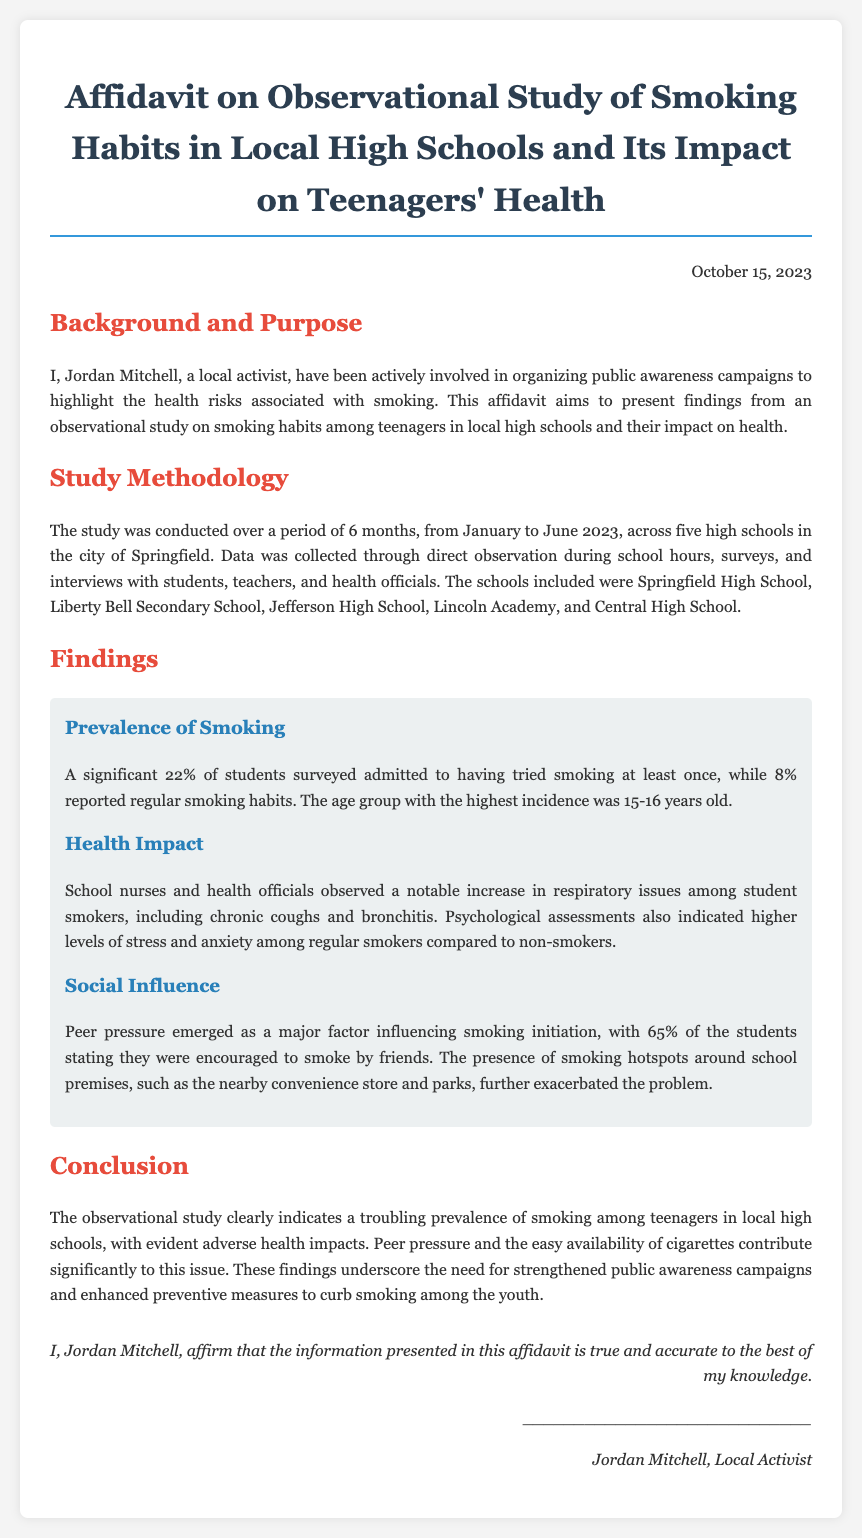What is the name of the local activist? The document states the local activist's name as Jordan Mitchell.
Answer: Jordan Mitchell What percentage of students reported regular smoking habits? The findings indicate that 8% of surveyed students reported regular smoking habits.
Answer: 8% How many high schools were included in the study? The document confirms that five high schools were part of the observational study.
Answer: five What age group had the highest incidence of smoking? The text specifies that the age group with the highest incidence was 15-16 years old.
Answer: 15-16 years old What psychological issues are noted among regular smokers? The affidavit mentions higher levels of stress and anxiety among regular smokers compared to non-smokers.
Answer: stress and anxiety What was the duration of the study? The document describes that the observational study was conducted over a period of 6 months.
Answer: 6 months What factor emerged as a major influence for smoking initiation? The findings revealed that peer pressure was a major factor influencing smoking initiation among students.
Answer: peer pressure On what date was the affidavit signed? The document indicates that the affidavit was signed on October 15, 2023.
Answer: October 15, 2023 What was the primary intent of the affidavit? The affidavit aims to present findings from an observational study on smoking habits and their health impact on teenagers.
Answer: present findings 